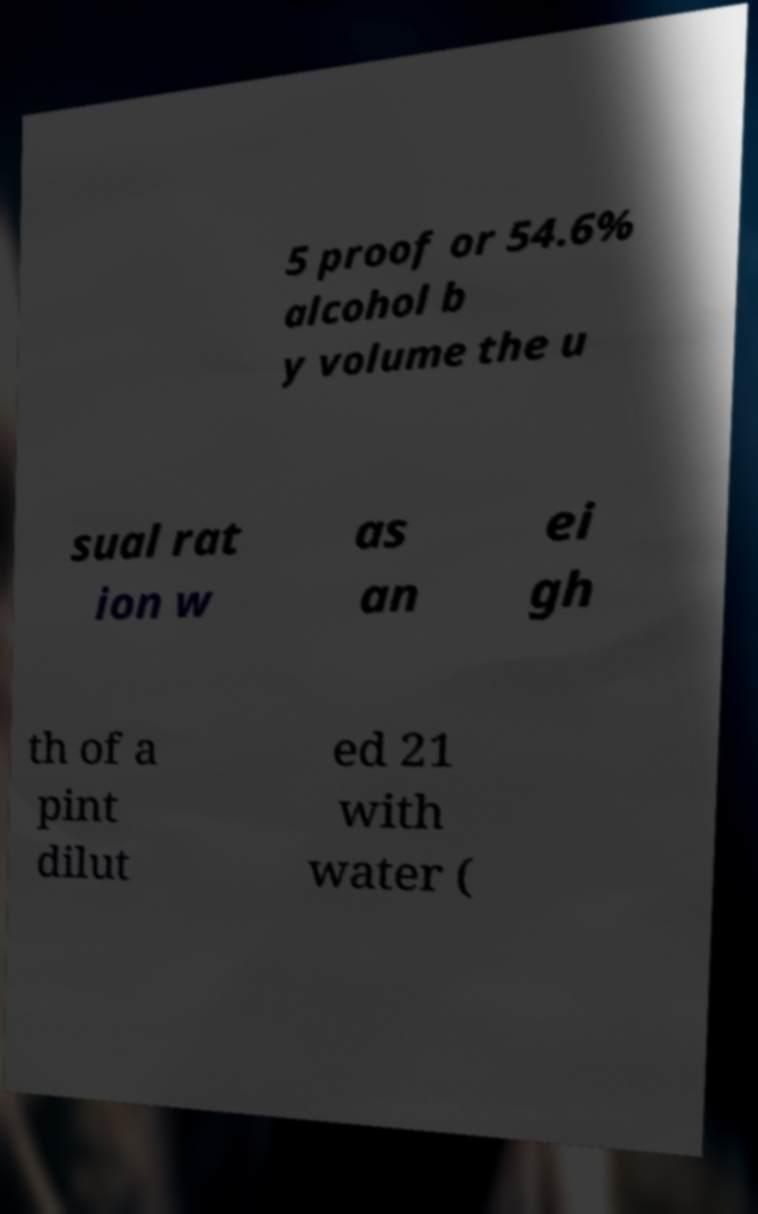What messages or text are displayed in this image? I need them in a readable, typed format. 5 proof or 54.6% alcohol b y volume the u sual rat ion w as an ei gh th of a pint dilut ed 21 with water ( 